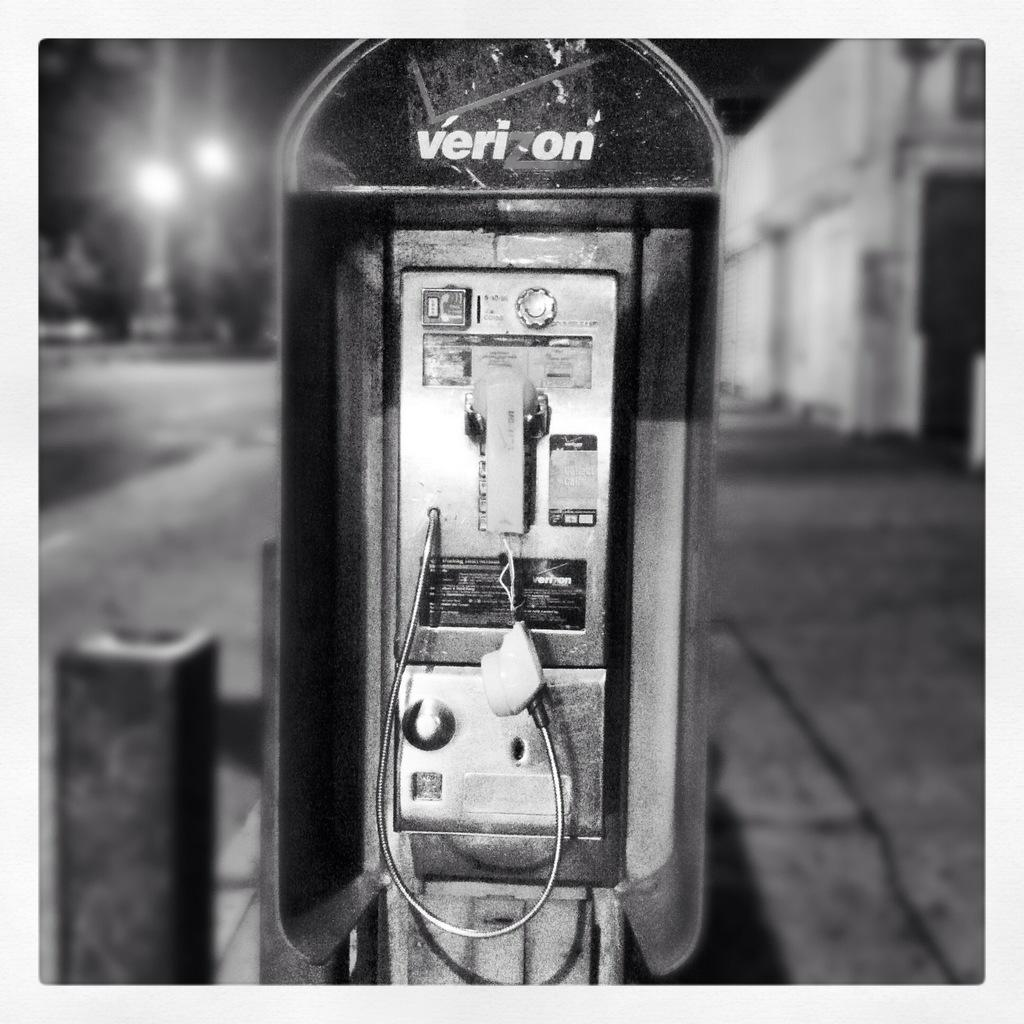<image>
Offer a succinct explanation of the picture presented. A battered and abused public phone is adorned with the Verizon logo. 